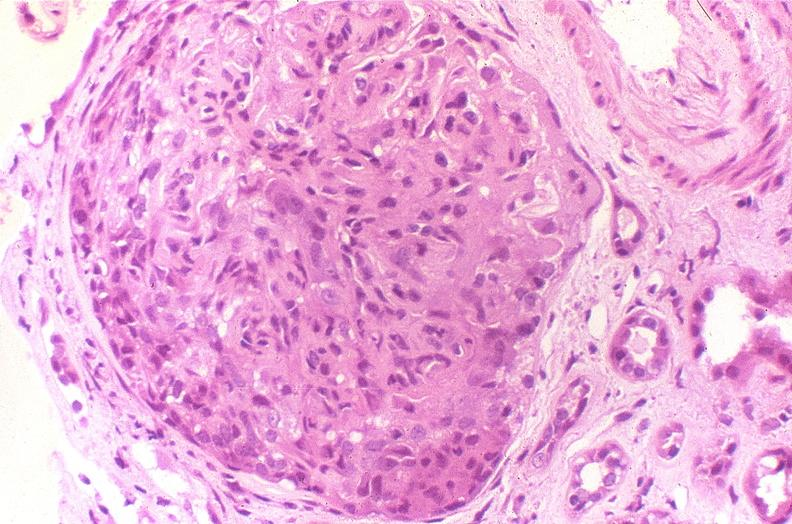what does this image show?
Answer the question using a single word or phrase. Glomerulonephritis 